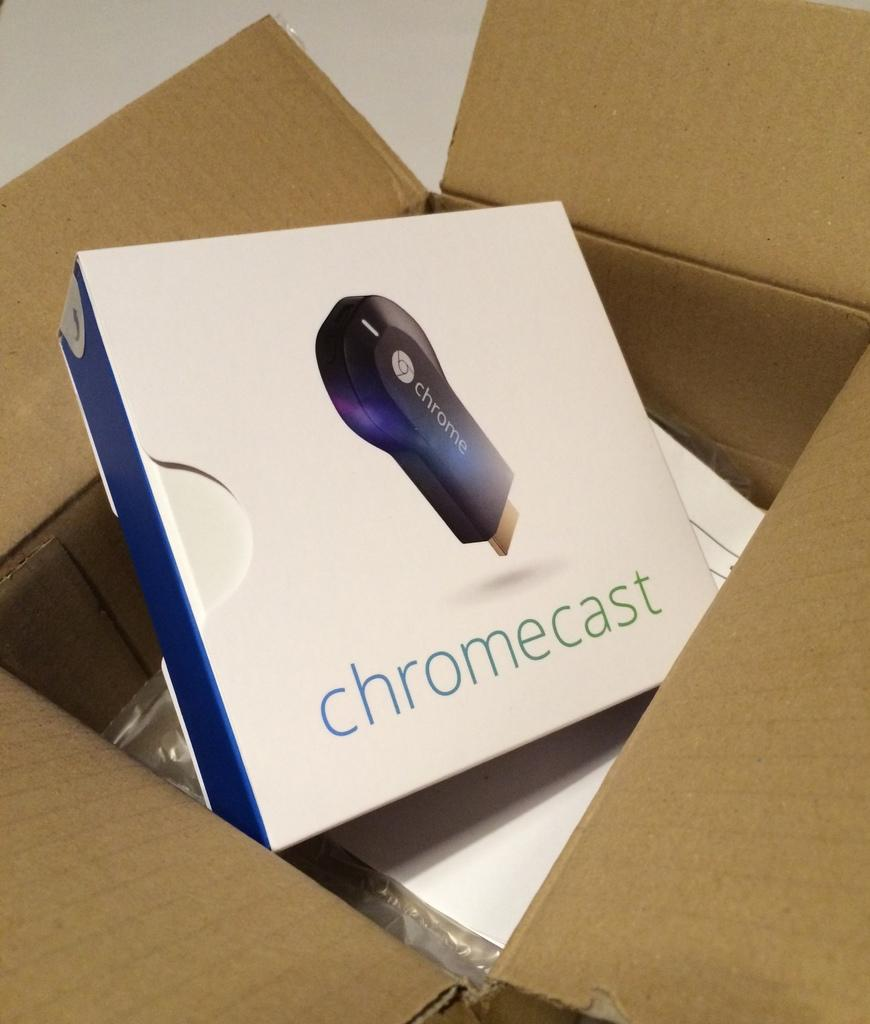Provide a one-sentence caption for the provided image. A Chromecast box is sitting inside a brown cardboard box. 